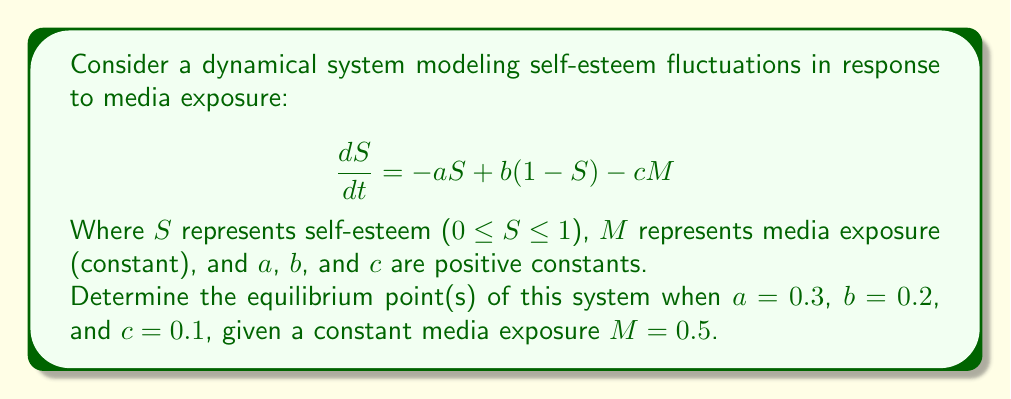Give your solution to this math problem. To find the equilibrium point(s), we need to set $\frac{dS}{dt} = 0$ and solve for $S$:

1) Set the equation equal to zero:
   $$0 = -aS + b(1-S) - cM$$

2) Substitute the given values:
   $$0 = -0.3S + 0.2(1-S) - 0.1(0.5)$$

3) Simplify:
   $$0 = -0.3S + 0.2 - 0.2S - 0.05$$
   $$0 = -0.5S + 0.15$$

4) Solve for S:
   $$0.5S = 0.15$$
   $$S = \frac{0.15}{0.5} = 0.3$$

5) Verify that 0 ≤ S ≤ 1:
   Indeed, 0.3 is within the valid range for S.

Therefore, the system has one equilibrium point at S = 0.3.
Answer: S = 0.3 